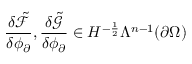<formula> <loc_0><loc_0><loc_500><loc_500>\frac { \delta \tilde { \mathcal { F } } } { \delta \phi _ { \partial } } , \frac { \delta \tilde { \mathcal { G } } } { \delta \phi _ { \partial } } \in H ^ { - \frac { 1 } { 2 } } \Lambda ^ { n - 1 } ( \partial \Omega )</formula> 